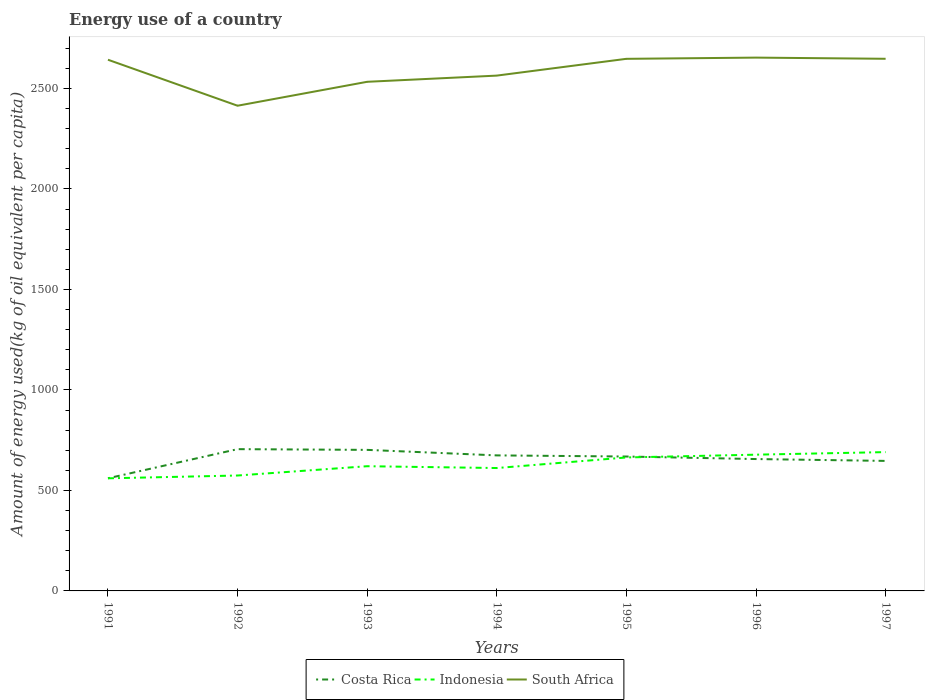Does the line corresponding to Indonesia intersect with the line corresponding to Costa Rica?
Provide a succinct answer. Yes. Is the number of lines equal to the number of legend labels?
Make the answer very short. Yes. Across all years, what is the maximum amount of energy used in in Costa Rica?
Provide a short and direct response. 560.53. What is the total amount of energy used in in Indonesia in the graph?
Ensure brevity in your answer.  -117.7. What is the difference between the highest and the second highest amount of energy used in in South Africa?
Provide a short and direct response. 239.41. How many lines are there?
Offer a terse response. 3. Are the values on the major ticks of Y-axis written in scientific E-notation?
Give a very brief answer. No. Does the graph contain any zero values?
Give a very brief answer. No. Does the graph contain grids?
Make the answer very short. No. How are the legend labels stacked?
Ensure brevity in your answer.  Horizontal. What is the title of the graph?
Provide a short and direct response. Energy use of a country. What is the label or title of the X-axis?
Make the answer very short. Years. What is the label or title of the Y-axis?
Your response must be concise. Amount of energy used(kg of oil equivalent per capita). What is the Amount of energy used(kg of oil equivalent per capita) in Costa Rica in 1991?
Your response must be concise. 560.53. What is the Amount of energy used(kg of oil equivalent per capita) in Indonesia in 1991?
Your answer should be compact. 560.33. What is the Amount of energy used(kg of oil equivalent per capita) in South Africa in 1991?
Your answer should be compact. 2643.27. What is the Amount of energy used(kg of oil equivalent per capita) in Costa Rica in 1992?
Give a very brief answer. 705.49. What is the Amount of energy used(kg of oil equivalent per capita) in Indonesia in 1992?
Keep it short and to the point. 574.3. What is the Amount of energy used(kg of oil equivalent per capita) in South Africa in 1992?
Keep it short and to the point. 2414.4. What is the Amount of energy used(kg of oil equivalent per capita) of Costa Rica in 1993?
Provide a succinct answer. 701.87. What is the Amount of energy used(kg of oil equivalent per capita) of Indonesia in 1993?
Offer a very short reply. 620.54. What is the Amount of energy used(kg of oil equivalent per capita) in South Africa in 1993?
Give a very brief answer. 2533.45. What is the Amount of energy used(kg of oil equivalent per capita) in Costa Rica in 1994?
Keep it short and to the point. 674.41. What is the Amount of energy used(kg of oil equivalent per capita) in Indonesia in 1994?
Offer a terse response. 611.52. What is the Amount of energy used(kg of oil equivalent per capita) in South Africa in 1994?
Offer a terse response. 2564.27. What is the Amount of energy used(kg of oil equivalent per capita) of Costa Rica in 1995?
Offer a terse response. 668.78. What is the Amount of energy used(kg of oil equivalent per capita) in Indonesia in 1995?
Ensure brevity in your answer.  664.14. What is the Amount of energy used(kg of oil equivalent per capita) in South Africa in 1995?
Ensure brevity in your answer.  2647.77. What is the Amount of energy used(kg of oil equivalent per capita) in Costa Rica in 1996?
Provide a short and direct response. 656.18. What is the Amount of energy used(kg of oil equivalent per capita) in Indonesia in 1996?
Offer a terse response. 678.03. What is the Amount of energy used(kg of oil equivalent per capita) of South Africa in 1996?
Your answer should be very brief. 2653.81. What is the Amount of energy used(kg of oil equivalent per capita) in Costa Rica in 1997?
Your response must be concise. 647. What is the Amount of energy used(kg of oil equivalent per capita) in Indonesia in 1997?
Provide a succinct answer. 690.73. What is the Amount of energy used(kg of oil equivalent per capita) in South Africa in 1997?
Your response must be concise. 2648.01. Across all years, what is the maximum Amount of energy used(kg of oil equivalent per capita) in Costa Rica?
Your answer should be very brief. 705.49. Across all years, what is the maximum Amount of energy used(kg of oil equivalent per capita) in Indonesia?
Keep it short and to the point. 690.73. Across all years, what is the maximum Amount of energy used(kg of oil equivalent per capita) of South Africa?
Offer a terse response. 2653.81. Across all years, what is the minimum Amount of energy used(kg of oil equivalent per capita) of Costa Rica?
Your response must be concise. 560.53. Across all years, what is the minimum Amount of energy used(kg of oil equivalent per capita) of Indonesia?
Offer a very short reply. 560.33. Across all years, what is the minimum Amount of energy used(kg of oil equivalent per capita) in South Africa?
Make the answer very short. 2414.4. What is the total Amount of energy used(kg of oil equivalent per capita) in Costa Rica in the graph?
Provide a short and direct response. 4614.27. What is the total Amount of energy used(kg of oil equivalent per capita) of Indonesia in the graph?
Offer a terse response. 4399.57. What is the total Amount of energy used(kg of oil equivalent per capita) in South Africa in the graph?
Your answer should be very brief. 1.81e+04. What is the difference between the Amount of energy used(kg of oil equivalent per capita) in Costa Rica in 1991 and that in 1992?
Your response must be concise. -144.96. What is the difference between the Amount of energy used(kg of oil equivalent per capita) of Indonesia in 1991 and that in 1992?
Give a very brief answer. -13.97. What is the difference between the Amount of energy used(kg of oil equivalent per capita) in South Africa in 1991 and that in 1992?
Make the answer very short. 228.87. What is the difference between the Amount of energy used(kg of oil equivalent per capita) of Costa Rica in 1991 and that in 1993?
Offer a terse response. -141.34. What is the difference between the Amount of energy used(kg of oil equivalent per capita) of Indonesia in 1991 and that in 1993?
Ensure brevity in your answer.  -60.21. What is the difference between the Amount of energy used(kg of oil equivalent per capita) in South Africa in 1991 and that in 1993?
Make the answer very short. 109.82. What is the difference between the Amount of energy used(kg of oil equivalent per capita) in Costa Rica in 1991 and that in 1994?
Your response must be concise. -113.88. What is the difference between the Amount of energy used(kg of oil equivalent per capita) of Indonesia in 1991 and that in 1994?
Offer a very short reply. -51.19. What is the difference between the Amount of energy used(kg of oil equivalent per capita) in South Africa in 1991 and that in 1994?
Your response must be concise. 79. What is the difference between the Amount of energy used(kg of oil equivalent per capita) of Costa Rica in 1991 and that in 1995?
Your answer should be compact. -108.25. What is the difference between the Amount of energy used(kg of oil equivalent per capita) of Indonesia in 1991 and that in 1995?
Provide a short and direct response. -103.81. What is the difference between the Amount of energy used(kg of oil equivalent per capita) of South Africa in 1991 and that in 1995?
Your response must be concise. -4.51. What is the difference between the Amount of energy used(kg of oil equivalent per capita) of Costa Rica in 1991 and that in 1996?
Offer a very short reply. -95.65. What is the difference between the Amount of energy used(kg of oil equivalent per capita) of Indonesia in 1991 and that in 1996?
Offer a very short reply. -117.7. What is the difference between the Amount of energy used(kg of oil equivalent per capita) in South Africa in 1991 and that in 1996?
Your response must be concise. -10.54. What is the difference between the Amount of energy used(kg of oil equivalent per capita) of Costa Rica in 1991 and that in 1997?
Offer a very short reply. -86.47. What is the difference between the Amount of energy used(kg of oil equivalent per capita) in Indonesia in 1991 and that in 1997?
Provide a succinct answer. -130.4. What is the difference between the Amount of energy used(kg of oil equivalent per capita) of South Africa in 1991 and that in 1997?
Give a very brief answer. -4.74. What is the difference between the Amount of energy used(kg of oil equivalent per capita) of Costa Rica in 1992 and that in 1993?
Your response must be concise. 3.62. What is the difference between the Amount of energy used(kg of oil equivalent per capita) in Indonesia in 1992 and that in 1993?
Keep it short and to the point. -46.24. What is the difference between the Amount of energy used(kg of oil equivalent per capita) of South Africa in 1992 and that in 1993?
Provide a succinct answer. -119.05. What is the difference between the Amount of energy used(kg of oil equivalent per capita) in Costa Rica in 1992 and that in 1994?
Your response must be concise. 31.07. What is the difference between the Amount of energy used(kg of oil equivalent per capita) of Indonesia in 1992 and that in 1994?
Ensure brevity in your answer.  -37.22. What is the difference between the Amount of energy used(kg of oil equivalent per capita) of South Africa in 1992 and that in 1994?
Give a very brief answer. -149.87. What is the difference between the Amount of energy used(kg of oil equivalent per capita) in Costa Rica in 1992 and that in 1995?
Keep it short and to the point. 36.71. What is the difference between the Amount of energy used(kg of oil equivalent per capita) of Indonesia in 1992 and that in 1995?
Provide a succinct answer. -89.85. What is the difference between the Amount of energy used(kg of oil equivalent per capita) of South Africa in 1992 and that in 1995?
Ensure brevity in your answer.  -233.38. What is the difference between the Amount of energy used(kg of oil equivalent per capita) in Costa Rica in 1992 and that in 1996?
Provide a short and direct response. 49.3. What is the difference between the Amount of energy used(kg of oil equivalent per capita) of Indonesia in 1992 and that in 1996?
Your answer should be very brief. -103.73. What is the difference between the Amount of energy used(kg of oil equivalent per capita) of South Africa in 1992 and that in 1996?
Offer a very short reply. -239.41. What is the difference between the Amount of energy used(kg of oil equivalent per capita) of Costa Rica in 1992 and that in 1997?
Provide a short and direct response. 58.48. What is the difference between the Amount of energy used(kg of oil equivalent per capita) in Indonesia in 1992 and that in 1997?
Provide a succinct answer. -116.43. What is the difference between the Amount of energy used(kg of oil equivalent per capita) in South Africa in 1992 and that in 1997?
Offer a terse response. -233.61. What is the difference between the Amount of energy used(kg of oil equivalent per capita) in Costa Rica in 1993 and that in 1994?
Provide a succinct answer. 27.45. What is the difference between the Amount of energy used(kg of oil equivalent per capita) of Indonesia in 1993 and that in 1994?
Your answer should be very brief. 9.02. What is the difference between the Amount of energy used(kg of oil equivalent per capita) of South Africa in 1993 and that in 1994?
Offer a very short reply. -30.82. What is the difference between the Amount of energy used(kg of oil equivalent per capita) of Costa Rica in 1993 and that in 1995?
Your answer should be compact. 33.09. What is the difference between the Amount of energy used(kg of oil equivalent per capita) in Indonesia in 1993 and that in 1995?
Make the answer very short. -43.6. What is the difference between the Amount of energy used(kg of oil equivalent per capita) in South Africa in 1993 and that in 1995?
Your answer should be very brief. -114.32. What is the difference between the Amount of energy used(kg of oil equivalent per capita) of Costa Rica in 1993 and that in 1996?
Offer a terse response. 45.68. What is the difference between the Amount of energy used(kg of oil equivalent per capita) of Indonesia in 1993 and that in 1996?
Your answer should be compact. -57.49. What is the difference between the Amount of energy used(kg of oil equivalent per capita) of South Africa in 1993 and that in 1996?
Give a very brief answer. -120.36. What is the difference between the Amount of energy used(kg of oil equivalent per capita) in Costa Rica in 1993 and that in 1997?
Your answer should be compact. 54.86. What is the difference between the Amount of energy used(kg of oil equivalent per capita) of Indonesia in 1993 and that in 1997?
Give a very brief answer. -70.19. What is the difference between the Amount of energy used(kg of oil equivalent per capita) in South Africa in 1993 and that in 1997?
Offer a very short reply. -114.56. What is the difference between the Amount of energy used(kg of oil equivalent per capita) in Costa Rica in 1994 and that in 1995?
Your answer should be very brief. 5.63. What is the difference between the Amount of energy used(kg of oil equivalent per capita) of Indonesia in 1994 and that in 1995?
Your response must be concise. -52.63. What is the difference between the Amount of energy used(kg of oil equivalent per capita) of South Africa in 1994 and that in 1995?
Your answer should be compact. -83.51. What is the difference between the Amount of energy used(kg of oil equivalent per capita) in Costa Rica in 1994 and that in 1996?
Keep it short and to the point. 18.23. What is the difference between the Amount of energy used(kg of oil equivalent per capita) in Indonesia in 1994 and that in 1996?
Your answer should be very brief. -66.51. What is the difference between the Amount of energy used(kg of oil equivalent per capita) in South Africa in 1994 and that in 1996?
Offer a terse response. -89.54. What is the difference between the Amount of energy used(kg of oil equivalent per capita) of Costa Rica in 1994 and that in 1997?
Offer a terse response. 27.41. What is the difference between the Amount of energy used(kg of oil equivalent per capita) in Indonesia in 1994 and that in 1997?
Give a very brief answer. -79.21. What is the difference between the Amount of energy used(kg of oil equivalent per capita) in South Africa in 1994 and that in 1997?
Make the answer very short. -83.74. What is the difference between the Amount of energy used(kg of oil equivalent per capita) in Costa Rica in 1995 and that in 1996?
Make the answer very short. 12.6. What is the difference between the Amount of energy used(kg of oil equivalent per capita) of Indonesia in 1995 and that in 1996?
Provide a succinct answer. -13.88. What is the difference between the Amount of energy used(kg of oil equivalent per capita) in South Africa in 1995 and that in 1996?
Provide a short and direct response. -6.03. What is the difference between the Amount of energy used(kg of oil equivalent per capita) of Costa Rica in 1995 and that in 1997?
Your answer should be compact. 21.78. What is the difference between the Amount of energy used(kg of oil equivalent per capita) of Indonesia in 1995 and that in 1997?
Keep it short and to the point. -26.59. What is the difference between the Amount of energy used(kg of oil equivalent per capita) of South Africa in 1995 and that in 1997?
Your answer should be very brief. -0.23. What is the difference between the Amount of energy used(kg of oil equivalent per capita) in Costa Rica in 1996 and that in 1997?
Offer a terse response. 9.18. What is the difference between the Amount of energy used(kg of oil equivalent per capita) of Indonesia in 1996 and that in 1997?
Provide a short and direct response. -12.7. What is the difference between the Amount of energy used(kg of oil equivalent per capita) in South Africa in 1996 and that in 1997?
Ensure brevity in your answer.  5.8. What is the difference between the Amount of energy used(kg of oil equivalent per capita) in Costa Rica in 1991 and the Amount of energy used(kg of oil equivalent per capita) in Indonesia in 1992?
Offer a terse response. -13.77. What is the difference between the Amount of energy used(kg of oil equivalent per capita) in Costa Rica in 1991 and the Amount of energy used(kg of oil equivalent per capita) in South Africa in 1992?
Your response must be concise. -1853.87. What is the difference between the Amount of energy used(kg of oil equivalent per capita) in Indonesia in 1991 and the Amount of energy used(kg of oil equivalent per capita) in South Africa in 1992?
Make the answer very short. -1854.07. What is the difference between the Amount of energy used(kg of oil equivalent per capita) of Costa Rica in 1991 and the Amount of energy used(kg of oil equivalent per capita) of Indonesia in 1993?
Keep it short and to the point. -60.01. What is the difference between the Amount of energy used(kg of oil equivalent per capita) in Costa Rica in 1991 and the Amount of energy used(kg of oil equivalent per capita) in South Africa in 1993?
Provide a succinct answer. -1972.92. What is the difference between the Amount of energy used(kg of oil equivalent per capita) of Indonesia in 1991 and the Amount of energy used(kg of oil equivalent per capita) of South Africa in 1993?
Your answer should be very brief. -1973.12. What is the difference between the Amount of energy used(kg of oil equivalent per capita) in Costa Rica in 1991 and the Amount of energy used(kg of oil equivalent per capita) in Indonesia in 1994?
Provide a short and direct response. -50.99. What is the difference between the Amount of energy used(kg of oil equivalent per capita) of Costa Rica in 1991 and the Amount of energy used(kg of oil equivalent per capita) of South Africa in 1994?
Ensure brevity in your answer.  -2003.74. What is the difference between the Amount of energy used(kg of oil equivalent per capita) in Indonesia in 1991 and the Amount of energy used(kg of oil equivalent per capita) in South Africa in 1994?
Ensure brevity in your answer.  -2003.94. What is the difference between the Amount of energy used(kg of oil equivalent per capita) in Costa Rica in 1991 and the Amount of energy used(kg of oil equivalent per capita) in Indonesia in 1995?
Provide a succinct answer. -103.61. What is the difference between the Amount of energy used(kg of oil equivalent per capita) in Costa Rica in 1991 and the Amount of energy used(kg of oil equivalent per capita) in South Africa in 1995?
Ensure brevity in your answer.  -2087.24. What is the difference between the Amount of energy used(kg of oil equivalent per capita) of Indonesia in 1991 and the Amount of energy used(kg of oil equivalent per capita) of South Africa in 1995?
Your answer should be very brief. -2087.44. What is the difference between the Amount of energy used(kg of oil equivalent per capita) of Costa Rica in 1991 and the Amount of energy used(kg of oil equivalent per capita) of Indonesia in 1996?
Provide a short and direct response. -117.49. What is the difference between the Amount of energy used(kg of oil equivalent per capita) in Costa Rica in 1991 and the Amount of energy used(kg of oil equivalent per capita) in South Africa in 1996?
Provide a short and direct response. -2093.28. What is the difference between the Amount of energy used(kg of oil equivalent per capita) in Indonesia in 1991 and the Amount of energy used(kg of oil equivalent per capita) in South Africa in 1996?
Provide a succinct answer. -2093.48. What is the difference between the Amount of energy used(kg of oil equivalent per capita) in Costa Rica in 1991 and the Amount of energy used(kg of oil equivalent per capita) in Indonesia in 1997?
Your answer should be very brief. -130.2. What is the difference between the Amount of energy used(kg of oil equivalent per capita) in Costa Rica in 1991 and the Amount of energy used(kg of oil equivalent per capita) in South Africa in 1997?
Your answer should be compact. -2087.48. What is the difference between the Amount of energy used(kg of oil equivalent per capita) of Indonesia in 1991 and the Amount of energy used(kg of oil equivalent per capita) of South Africa in 1997?
Your answer should be compact. -2087.68. What is the difference between the Amount of energy used(kg of oil equivalent per capita) in Costa Rica in 1992 and the Amount of energy used(kg of oil equivalent per capita) in Indonesia in 1993?
Ensure brevity in your answer.  84.95. What is the difference between the Amount of energy used(kg of oil equivalent per capita) in Costa Rica in 1992 and the Amount of energy used(kg of oil equivalent per capita) in South Africa in 1993?
Provide a succinct answer. -1827.96. What is the difference between the Amount of energy used(kg of oil equivalent per capita) of Indonesia in 1992 and the Amount of energy used(kg of oil equivalent per capita) of South Africa in 1993?
Keep it short and to the point. -1959.15. What is the difference between the Amount of energy used(kg of oil equivalent per capita) of Costa Rica in 1992 and the Amount of energy used(kg of oil equivalent per capita) of Indonesia in 1994?
Make the answer very short. 93.97. What is the difference between the Amount of energy used(kg of oil equivalent per capita) in Costa Rica in 1992 and the Amount of energy used(kg of oil equivalent per capita) in South Africa in 1994?
Keep it short and to the point. -1858.78. What is the difference between the Amount of energy used(kg of oil equivalent per capita) of Indonesia in 1992 and the Amount of energy used(kg of oil equivalent per capita) of South Africa in 1994?
Keep it short and to the point. -1989.97. What is the difference between the Amount of energy used(kg of oil equivalent per capita) in Costa Rica in 1992 and the Amount of energy used(kg of oil equivalent per capita) in Indonesia in 1995?
Ensure brevity in your answer.  41.35. What is the difference between the Amount of energy used(kg of oil equivalent per capita) of Costa Rica in 1992 and the Amount of energy used(kg of oil equivalent per capita) of South Africa in 1995?
Provide a succinct answer. -1942.29. What is the difference between the Amount of energy used(kg of oil equivalent per capita) of Indonesia in 1992 and the Amount of energy used(kg of oil equivalent per capita) of South Africa in 1995?
Offer a terse response. -2073.48. What is the difference between the Amount of energy used(kg of oil equivalent per capita) in Costa Rica in 1992 and the Amount of energy used(kg of oil equivalent per capita) in Indonesia in 1996?
Give a very brief answer. 27.46. What is the difference between the Amount of energy used(kg of oil equivalent per capita) of Costa Rica in 1992 and the Amount of energy used(kg of oil equivalent per capita) of South Africa in 1996?
Offer a terse response. -1948.32. What is the difference between the Amount of energy used(kg of oil equivalent per capita) of Indonesia in 1992 and the Amount of energy used(kg of oil equivalent per capita) of South Africa in 1996?
Provide a short and direct response. -2079.51. What is the difference between the Amount of energy used(kg of oil equivalent per capita) of Costa Rica in 1992 and the Amount of energy used(kg of oil equivalent per capita) of Indonesia in 1997?
Provide a short and direct response. 14.76. What is the difference between the Amount of energy used(kg of oil equivalent per capita) in Costa Rica in 1992 and the Amount of energy used(kg of oil equivalent per capita) in South Africa in 1997?
Your answer should be compact. -1942.52. What is the difference between the Amount of energy used(kg of oil equivalent per capita) of Indonesia in 1992 and the Amount of energy used(kg of oil equivalent per capita) of South Africa in 1997?
Give a very brief answer. -2073.71. What is the difference between the Amount of energy used(kg of oil equivalent per capita) of Costa Rica in 1993 and the Amount of energy used(kg of oil equivalent per capita) of Indonesia in 1994?
Your answer should be compact. 90.35. What is the difference between the Amount of energy used(kg of oil equivalent per capita) in Costa Rica in 1993 and the Amount of energy used(kg of oil equivalent per capita) in South Africa in 1994?
Offer a terse response. -1862.4. What is the difference between the Amount of energy used(kg of oil equivalent per capita) of Indonesia in 1993 and the Amount of energy used(kg of oil equivalent per capita) of South Africa in 1994?
Offer a very short reply. -1943.73. What is the difference between the Amount of energy used(kg of oil equivalent per capita) in Costa Rica in 1993 and the Amount of energy used(kg of oil equivalent per capita) in Indonesia in 1995?
Give a very brief answer. 37.73. What is the difference between the Amount of energy used(kg of oil equivalent per capita) of Costa Rica in 1993 and the Amount of energy used(kg of oil equivalent per capita) of South Africa in 1995?
Keep it short and to the point. -1945.91. What is the difference between the Amount of energy used(kg of oil equivalent per capita) of Indonesia in 1993 and the Amount of energy used(kg of oil equivalent per capita) of South Africa in 1995?
Make the answer very short. -2027.24. What is the difference between the Amount of energy used(kg of oil equivalent per capita) of Costa Rica in 1993 and the Amount of energy used(kg of oil equivalent per capita) of Indonesia in 1996?
Give a very brief answer. 23.84. What is the difference between the Amount of energy used(kg of oil equivalent per capita) in Costa Rica in 1993 and the Amount of energy used(kg of oil equivalent per capita) in South Africa in 1996?
Provide a short and direct response. -1951.94. What is the difference between the Amount of energy used(kg of oil equivalent per capita) of Indonesia in 1993 and the Amount of energy used(kg of oil equivalent per capita) of South Africa in 1996?
Your answer should be compact. -2033.27. What is the difference between the Amount of energy used(kg of oil equivalent per capita) in Costa Rica in 1993 and the Amount of energy used(kg of oil equivalent per capita) in Indonesia in 1997?
Offer a terse response. 11.14. What is the difference between the Amount of energy used(kg of oil equivalent per capita) in Costa Rica in 1993 and the Amount of energy used(kg of oil equivalent per capita) in South Africa in 1997?
Provide a short and direct response. -1946.14. What is the difference between the Amount of energy used(kg of oil equivalent per capita) in Indonesia in 1993 and the Amount of energy used(kg of oil equivalent per capita) in South Africa in 1997?
Offer a very short reply. -2027.47. What is the difference between the Amount of energy used(kg of oil equivalent per capita) in Costa Rica in 1994 and the Amount of energy used(kg of oil equivalent per capita) in Indonesia in 1995?
Your answer should be very brief. 10.27. What is the difference between the Amount of energy used(kg of oil equivalent per capita) in Costa Rica in 1994 and the Amount of energy used(kg of oil equivalent per capita) in South Africa in 1995?
Offer a very short reply. -1973.36. What is the difference between the Amount of energy used(kg of oil equivalent per capita) in Indonesia in 1994 and the Amount of energy used(kg of oil equivalent per capita) in South Africa in 1995?
Offer a very short reply. -2036.26. What is the difference between the Amount of energy used(kg of oil equivalent per capita) of Costa Rica in 1994 and the Amount of energy used(kg of oil equivalent per capita) of Indonesia in 1996?
Provide a succinct answer. -3.61. What is the difference between the Amount of energy used(kg of oil equivalent per capita) of Costa Rica in 1994 and the Amount of energy used(kg of oil equivalent per capita) of South Africa in 1996?
Offer a very short reply. -1979.39. What is the difference between the Amount of energy used(kg of oil equivalent per capita) in Indonesia in 1994 and the Amount of energy used(kg of oil equivalent per capita) in South Africa in 1996?
Offer a terse response. -2042.29. What is the difference between the Amount of energy used(kg of oil equivalent per capita) in Costa Rica in 1994 and the Amount of energy used(kg of oil equivalent per capita) in Indonesia in 1997?
Give a very brief answer. -16.31. What is the difference between the Amount of energy used(kg of oil equivalent per capita) of Costa Rica in 1994 and the Amount of energy used(kg of oil equivalent per capita) of South Africa in 1997?
Provide a succinct answer. -1973.59. What is the difference between the Amount of energy used(kg of oil equivalent per capita) in Indonesia in 1994 and the Amount of energy used(kg of oil equivalent per capita) in South Africa in 1997?
Give a very brief answer. -2036.49. What is the difference between the Amount of energy used(kg of oil equivalent per capita) of Costa Rica in 1995 and the Amount of energy used(kg of oil equivalent per capita) of Indonesia in 1996?
Provide a short and direct response. -9.24. What is the difference between the Amount of energy used(kg of oil equivalent per capita) of Costa Rica in 1995 and the Amount of energy used(kg of oil equivalent per capita) of South Africa in 1996?
Provide a succinct answer. -1985.02. What is the difference between the Amount of energy used(kg of oil equivalent per capita) in Indonesia in 1995 and the Amount of energy used(kg of oil equivalent per capita) in South Africa in 1996?
Your answer should be compact. -1989.66. What is the difference between the Amount of energy used(kg of oil equivalent per capita) of Costa Rica in 1995 and the Amount of energy used(kg of oil equivalent per capita) of Indonesia in 1997?
Your response must be concise. -21.95. What is the difference between the Amount of energy used(kg of oil equivalent per capita) in Costa Rica in 1995 and the Amount of energy used(kg of oil equivalent per capita) in South Africa in 1997?
Ensure brevity in your answer.  -1979.22. What is the difference between the Amount of energy used(kg of oil equivalent per capita) in Indonesia in 1995 and the Amount of energy used(kg of oil equivalent per capita) in South Africa in 1997?
Your response must be concise. -1983.87. What is the difference between the Amount of energy used(kg of oil equivalent per capita) of Costa Rica in 1996 and the Amount of energy used(kg of oil equivalent per capita) of Indonesia in 1997?
Your response must be concise. -34.54. What is the difference between the Amount of energy used(kg of oil equivalent per capita) in Costa Rica in 1996 and the Amount of energy used(kg of oil equivalent per capita) in South Africa in 1997?
Provide a succinct answer. -1991.82. What is the difference between the Amount of energy used(kg of oil equivalent per capita) of Indonesia in 1996 and the Amount of energy used(kg of oil equivalent per capita) of South Africa in 1997?
Offer a very short reply. -1969.98. What is the average Amount of energy used(kg of oil equivalent per capita) of Costa Rica per year?
Offer a terse response. 659.18. What is the average Amount of energy used(kg of oil equivalent per capita) of Indonesia per year?
Offer a very short reply. 628.51. What is the average Amount of energy used(kg of oil equivalent per capita) of South Africa per year?
Offer a terse response. 2586.42. In the year 1991, what is the difference between the Amount of energy used(kg of oil equivalent per capita) of Costa Rica and Amount of energy used(kg of oil equivalent per capita) of Indonesia?
Give a very brief answer. 0.2. In the year 1991, what is the difference between the Amount of energy used(kg of oil equivalent per capita) of Costa Rica and Amount of energy used(kg of oil equivalent per capita) of South Africa?
Your response must be concise. -2082.74. In the year 1991, what is the difference between the Amount of energy used(kg of oil equivalent per capita) of Indonesia and Amount of energy used(kg of oil equivalent per capita) of South Africa?
Ensure brevity in your answer.  -2082.94. In the year 1992, what is the difference between the Amount of energy used(kg of oil equivalent per capita) in Costa Rica and Amount of energy used(kg of oil equivalent per capita) in Indonesia?
Your answer should be very brief. 131.19. In the year 1992, what is the difference between the Amount of energy used(kg of oil equivalent per capita) of Costa Rica and Amount of energy used(kg of oil equivalent per capita) of South Africa?
Provide a short and direct response. -1708.91. In the year 1992, what is the difference between the Amount of energy used(kg of oil equivalent per capita) in Indonesia and Amount of energy used(kg of oil equivalent per capita) in South Africa?
Provide a short and direct response. -1840.1. In the year 1993, what is the difference between the Amount of energy used(kg of oil equivalent per capita) of Costa Rica and Amount of energy used(kg of oil equivalent per capita) of Indonesia?
Give a very brief answer. 81.33. In the year 1993, what is the difference between the Amount of energy used(kg of oil equivalent per capita) in Costa Rica and Amount of energy used(kg of oil equivalent per capita) in South Africa?
Your answer should be compact. -1831.58. In the year 1993, what is the difference between the Amount of energy used(kg of oil equivalent per capita) in Indonesia and Amount of energy used(kg of oil equivalent per capita) in South Africa?
Make the answer very short. -1912.91. In the year 1994, what is the difference between the Amount of energy used(kg of oil equivalent per capita) in Costa Rica and Amount of energy used(kg of oil equivalent per capita) in Indonesia?
Give a very brief answer. 62.9. In the year 1994, what is the difference between the Amount of energy used(kg of oil equivalent per capita) in Costa Rica and Amount of energy used(kg of oil equivalent per capita) in South Africa?
Make the answer very short. -1889.85. In the year 1994, what is the difference between the Amount of energy used(kg of oil equivalent per capita) in Indonesia and Amount of energy used(kg of oil equivalent per capita) in South Africa?
Your answer should be very brief. -1952.75. In the year 1995, what is the difference between the Amount of energy used(kg of oil equivalent per capita) in Costa Rica and Amount of energy used(kg of oil equivalent per capita) in Indonesia?
Make the answer very short. 4.64. In the year 1995, what is the difference between the Amount of energy used(kg of oil equivalent per capita) in Costa Rica and Amount of energy used(kg of oil equivalent per capita) in South Africa?
Ensure brevity in your answer.  -1978.99. In the year 1995, what is the difference between the Amount of energy used(kg of oil equivalent per capita) in Indonesia and Amount of energy used(kg of oil equivalent per capita) in South Africa?
Your response must be concise. -1983.63. In the year 1996, what is the difference between the Amount of energy used(kg of oil equivalent per capita) of Costa Rica and Amount of energy used(kg of oil equivalent per capita) of Indonesia?
Ensure brevity in your answer.  -21.84. In the year 1996, what is the difference between the Amount of energy used(kg of oil equivalent per capita) of Costa Rica and Amount of energy used(kg of oil equivalent per capita) of South Africa?
Offer a terse response. -1997.62. In the year 1996, what is the difference between the Amount of energy used(kg of oil equivalent per capita) in Indonesia and Amount of energy used(kg of oil equivalent per capita) in South Africa?
Your answer should be compact. -1975.78. In the year 1997, what is the difference between the Amount of energy used(kg of oil equivalent per capita) of Costa Rica and Amount of energy used(kg of oil equivalent per capita) of Indonesia?
Offer a very short reply. -43.72. In the year 1997, what is the difference between the Amount of energy used(kg of oil equivalent per capita) in Costa Rica and Amount of energy used(kg of oil equivalent per capita) in South Africa?
Your answer should be very brief. -2001. In the year 1997, what is the difference between the Amount of energy used(kg of oil equivalent per capita) of Indonesia and Amount of energy used(kg of oil equivalent per capita) of South Africa?
Give a very brief answer. -1957.28. What is the ratio of the Amount of energy used(kg of oil equivalent per capita) in Costa Rica in 1991 to that in 1992?
Provide a short and direct response. 0.79. What is the ratio of the Amount of energy used(kg of oil equivalent per capita) in Indonesia in 1991 to that in 1992?
Your response must be concise. 0.98. What is the ratio of the Amount of energy used(kg of oil equivalent per capita) in South Africa in 1991 to that in 1992?
Your answer should be very brief. 1.09. What is the ratio of the Amount of energy used(kg of oil equivalent per capita) of Costa Rica in 1991 to that in 1993?
Keep it short and to the point. 0.8. What is the ratio of the Amount of energy used(kg of oil equivalent per capita) of Indonesia in 1991 to that in 1993?
Ensure brevity in your answer.  0.9. What is the ratio of the Amount of energy used(kg of oil equivalent per capita) of South Africa in 1991 to that in 1993?
Ensure brevity in your answer.  1.04. What is the ratio of the Amount of energy used(kg of oil equivalent per capita) of Costa Rica in 1991 to that in 1994?
Provide a succinct answer. 0.83. What is the ratio of the Amount of energy used(kg of oil equivalent per capita) of Indonesia in 1991 to that in 1994?
Your response must be concise. 0.92. What is the ratio of the Amount of energy used(kg of oil equivalent per capita) in South Africa in 1991 to that in 1994?
Provide a short and direct response. 1.03. What is the ratio of the Amount of energy used(kg of oil equivalent per capita) in Costa Rica in 1991 to that in 1995?
Provide a succinct answer. 0.84. What is the ratio of the Amount of energy used(kg of oil equivalent per capita) of Indonesia in 1991 to that in 1995?
Keep it short and to the point. 0.84. What is the ratio of the Amount of energy used(kg of oil equivalent per capita) of South Africa in 1991 to that in 1995?
Your response must be concise. 1. What is the ratio of the Amount of energy used(kg of oil equivalent per capita) in Costa Rica in 1991 to that in 1996?
Provide a short and direct response. 0.85. What is the ratio of the Amount of energy used(kg of oil equivalent per capita) of Indonesia in 1991 to that in 1996?
Make the answer very short. 0.83. What is the ratio of the Amount of energy used(kg of oil equivalent per capita) in South Africa in 1991 to that in 1996?
Make the answer very short. 1. What is the ratio of the Amount of energy used(kg of oil equivalent per capita) of Costa Rica in 1991 to that in 1997?
Give a very brief answer. 0.87. What is the ratio of the Amount of energy used(kg of oil equivalent per capita) of Indonesia in 1991 to that in 1997?
Give a very brief answer. 0.81. What is the ratio of the Amount of energy used(kg of oil equivalent per capita) in South Africa in 1991 to that in 1997?
Make the answer very short. 1. What is the ratio of the Amount of energy used(kg of oil equivalent per capita) of Indonesia in 1992 to that in 1993?
Ensure brevity in your answer.  0.93. What is the ratio of the Amount of energy used(kg of oil equivalent per capita) of South Africa in 1992 to that in 1993?
Your answer should be compact. 0.95. What is the ratio of the Amount of energy used(kg of oil equivalent per capita) in Costa Rica in 1992 to that in 1994?
Your response must be concise. 1.05. What is the ratio of the Amount of energy used(kg of oil equivalent per capita) of Indonesia in 1992 to that in 1994?
Provide a short and direct response. 0.94. What is the ratio of the Amount of energy used(kg of oil equivalent per capita) in South Africa in 1992 to that in 1994?
Provide a succinct answer. 0.94. What is the ratio of the Amount of energy used(kg of oil equivalent per capita) of Costa Rica in 1992 to that in 1995?
Keep it short and to the point. 1.05. What is the ratio of the Amount of energy used(kg of oil equivalent per capita) of Indonesia in 1992 to that in 1995?
Provide a short and direct response. 0.86. What is the ratio of the Amount of energy used(kg of oil equivalent per capita) of South Africa in 1992 to that in 1995?
Your answer should be compact. 0.91. What is the ratio of the Amount of energy used(kg of oil equivalent per capita) in Costa Rica in 1992 to that in 1996?
Your answer should be very brief. 1.08. What is the ratio of the Amount of energy used(kg of oil equivalent per capita) in Indonesia in 1992 to that in 1996?
Your response must be concise. 0.85. What is the ratio of the Amount of energy used(kg of oil equivalent per capita) of South Africa in 1992 to that in 1996?
Your answer should be compact. 0.91. What is the ratio of the Amount of energy used(kg of oil equivalent per capita) in Costa Rica in 1992 to that in 1997?
Offer a terse response. 1.09. What is the ratio of the Amount of energy used(kg of oil equivalent per capita) in Indonesia in 1992 to that in 1997?
Ensure brevity in your answer.  0.83. What is the ratio of the Amount of energy used(kg of oil equivalent per capita) in South Africa in 1992 to that in 1997?
Provide a succinct answer. 0.91. What is the ratio of the Amount of energy used(kg of oil equivalent per capita) of Costa Rica in 1993 to that in 1994?
Make the answer very short. 1.04. What is the ratio of the Amount of energy used(kg of oil equivalent per capita) in Indonesia in 1993 to that in 1994?
Provide a succinct answer. 1.01. What is the ratio of the Amount of energy used(kg of oil equivalent per capita) of Costa Rica in 1993 to that in 1995?
Offer a very short reply. 1.05. What is the ratio of the Amount of energy used(kg of oil equivalent per capita) of Indonesia in 1993 to that in 1995?
Make the answer very short. 0.93. What is the ratio of the Amount of energy used(kg of oil equivalent per capita) of South Africa in 1993 to that in 1995?
Give a very brief answer. 0.96. What is the ratio of the Amount of energy used(kg of oil equivalent per capita) in Costa Rica in 1993 to that in 1996?
Make the answer very short. 1.07. What is the ratio of the Amount of energy used(kg of oil equivalent per capita) in Indonesia in 1993 to that in 1996?
Your answer should be compact. 0.92. What is the ratio of the Amount of energy used(kg of oil equivalent per capita) of South Africa in 1993 to that in 1996?
Offer a very short reply. 0.95. What is the ratio of the Amount of energy used(kg of oil equivalent per capita) of Costa Rica in 1993 to that in 1997?
Make the answer very short. 1.08. What is the ratio of the Amount of energy used(kg of oil equivalent per capita) of Indonesia in 1993 to that in 1997?
Your answer should be compact. 0.9. What is the ratio of the Amount of energy used(kg of oil equivalent per capita) in South Africa in 1993 to that in 1997?
Provide a short and direct response. 0.96. What is the ratio of the Amount of energy used(kg of oil equivalent per capita) of Costa Rica in 1994 to that in 1995?
Provide a succinct answer. 1.01. What is the ratio of the Amount of energy used(kg of oil equivalent per capita) of Indonesia in 1994 to that in 1995?
Give a very brief answer. 0.92. What is the ratio of the Amount of energy used(kg of oil equivalent per capita) of South Africa in 1994 to that in 1995?
Make the answer very short. 0.97. What is the ratio of the Amount of energy used(kg of oil equivalent per capita) of Costa Rica in 1994 to that in 1996?
Offer a terse response. 1.03. What is the ratio of the Amount of energy used(kg of oil equivalent per capita) of Indonesia in 1994 to that in 1996?
Your response must be concise. 0.9. What is the ratio of the Amount of energy used(kg of oil equivalent per capita) in South Africa in 1994 to that in 1996?
Your response must be concise. 0.97. What is the ratio of the Amount of energy used(kg of oil equivalent per capita) of Costa Rica in 1994 to that in 1997?
Keep it short and to the point. 1.04. What is the ratio of the Amount of energy used(kg of oil equivalent per capita) of Indonesia in 1994 to that in 1997?
Give a very brief answer. 0.89. What is the ratio of the Amount of energy used(kg of oil equivalent per capita) of South Africa in 1994 to that in 1997?
Your answer should be very brief. 0.97. What is the ratio of the Amount of energy used(kg of oil equivalent per capita) in Costa Rica in 1995 to that in 1996?
Your answer should be compact. 1.02. What is the ratio of the Amount of energy used(kg of oil equivalent per capita) of Indonesia in 1995 to that in 1996?
Provide a succinct answer. 0.98. What is the ratio of the Amount of energy used(kg of oil equivalent per capita) in South Africa in 1995 to that in 1996?
Your answer should be very brief. 1. What is the ratio of the Amount of energy used(kg of oil equivalent per capita) in Costa Rica in 1995 to that in 1997?
Ensure brevity in your answer.  1.03. What is the ratio of the Amount of energy used(kg of oil equivalent per capita) of Indonesia in 1995 to that in 1997?
Your answer should be very brief. 0.96. What is the ratio of the Amount of energy used(kg of oil equivalent per capita) in Costa Rica in 1996 to that in 1997?
Make the answer very short. 1.01. What is the ratio of the Amount of energy used(kg of oil equivalent per capita) of Indonesia in 1996 to that in 1997?
Your answer should be compact. 0.98. What is the difference between the highest and the second highest Amount of energy used(kg of oil equivalent per capita) in Costa Rica?
Provide a succinct answer. 3.62. What is the difference between the highest and the second highest Amount of energy used(kg of oil equivalent per capita) in Indonesia?
Your answer should be compact. 12.7. What is the difference between the highest and the second highest Amount of energy used(kg of oil equivalent per capita) of South Africa?
Your answer should be compact. 5.8. What is the difference between the highest and the lowest Amount of energy used(kg of oil equivalent per capita) in Costa Rica?
Offer a very short reply. 144.96. What is the difference between the highest and the lowest Amount of energy used(kg of oil equivalent per capita) in Indonesia?
Give a very brief answer. 130.4. What is the difference between the highest and the lowest Amount of energy used(kg of oil equivalent per capita) in South Africa?
Provide a succinct answer. 239.41. 